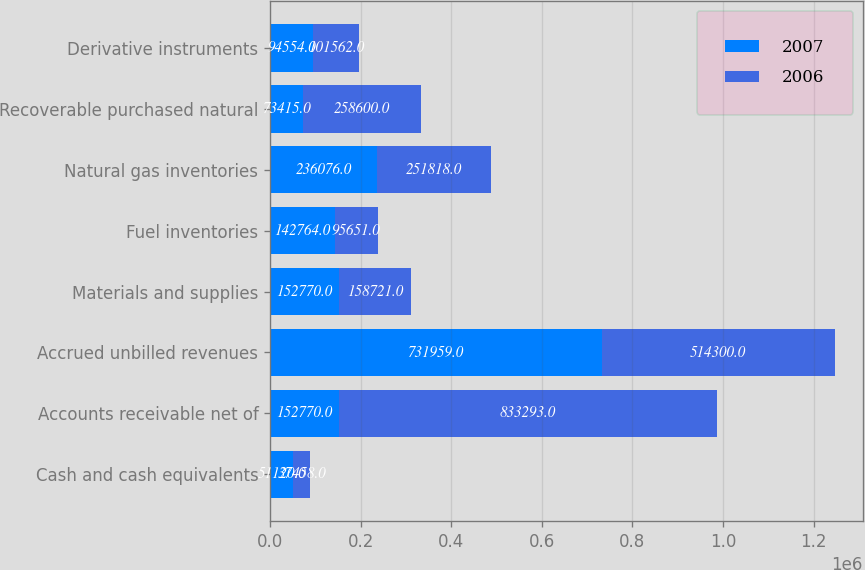Convert chart. <chart><loc_0><loc_0><loc_500><loc_500><stacked_bar_chart><ecel><fcel>Cash and cash equivalents<fcel>Accounts receivable net of<fcel>Accrued unbilled revenues<fcel>Materials and supplies<fcel>Fuel inventories<fcel>Natural gas inventories<fcel>Recoverable purchased natural<fcel>Derivative instruments<nl><fcel>2007<fcel>51120<fcel>152770<fcel>731959<fcel>152770<fcel>142764<fcel>236076<fcel>73415<fcel>94554<nl><fcel>2006<fcel>37458<fcel>833293<fcel>514300<fcel>158721<fcel>95651<fcel>251818<fcel>258600<fcel>101562<nl></chart> 